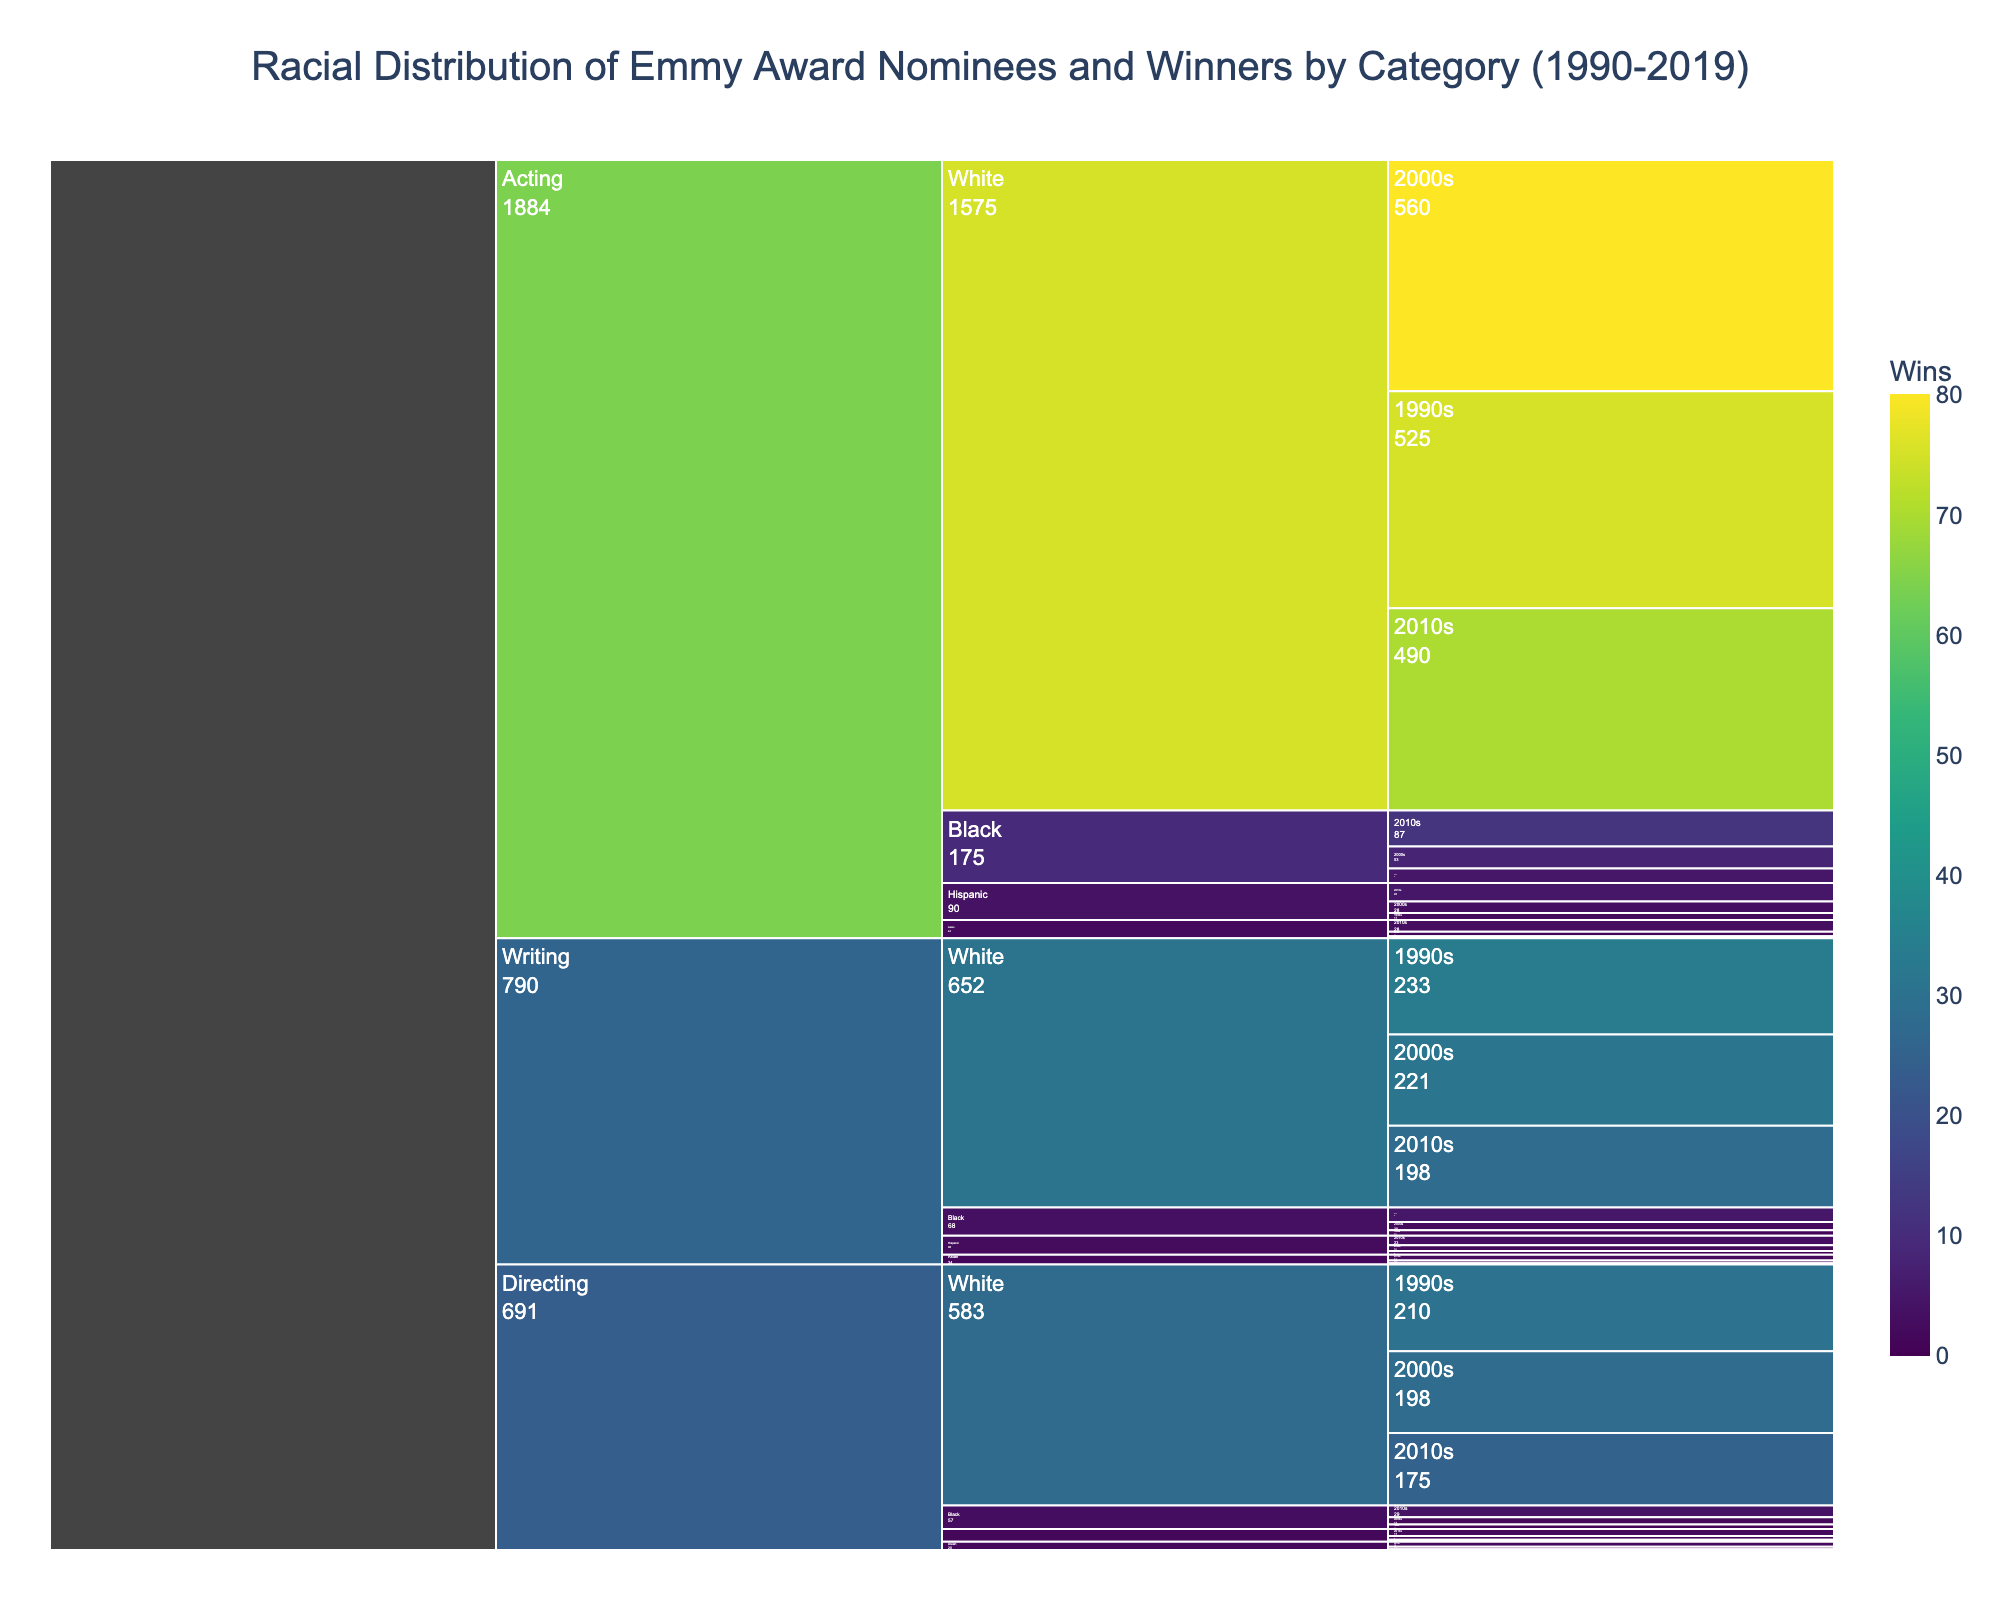what is the title of the chart? The title is usually displayed prominently at the top of the chart. In this case, the title is "Racial Distribution of Emmy Award Nominees and Winners by Category (1990-2019)."
Answer: Racial Distribution of Emmy Award Nominees and Winners by Category (1990-2019) Which racial group has the most wins in the 2010s for Acting? This can be determined by identifying the segment representing the 2010s within the Acting category and noting the racial group with the highest count of Wins.
Answer: White How many total nominations did Black actors receive in the 2000s? Go to the Acting category, then to the Black racial group, and locate the segment for the 2000s to find the total nominations.
Answer: 45 In which decade did Asian directors win more than Asian writers? Examine the segments for Asian directors and Asian writers within each decade. Compare their "Wins" values to determine which decade satisfies the condition.
Answer: 2000s Which racial group and decade have the smallest number of wins in Writing? Navigate to the Writing category and compare wins across all racial groups and decades. The smallest value is the answer.
Answer: Asian, 1990s Which category had the highest total value (nominations + wins) for Hispanic individuals? Sum the values for each category that includes Hispanic individuals and compare them. The category with the highest sum is the answer.
Answer: Acting How does the number of nominations for Black writers in the 1990s compare with those in the 2010s? Look at the Writing category, find the segment for Black writers in both the 1990s and 2010s, and compare the values for Nominations.
Answer: 12 in 1990s and 30 in 2010s What is the average number of wins for White directors across the three decades? Add the number of wins for White directors from the 1990s, 2000s, and 2010s. Then, divide the total by 3 to find the average. The steps are: (30 + 28 + 25) / 3.
Answer: 27.67 Which category and racial group have a decade with exactly no wins? Identify segments within each category where Wins are zero and note the corresponding racial group and decade.
Answer: Acting, Asian, 1990s Between Hispanic directors and Hispanic actors, who had more wins in the 2000s? Compare the Wins for Hispanic directors and Hispanic actors in the 2000s by checking their respective segments under the specified decade and category.
Answer: Hispanic actors 